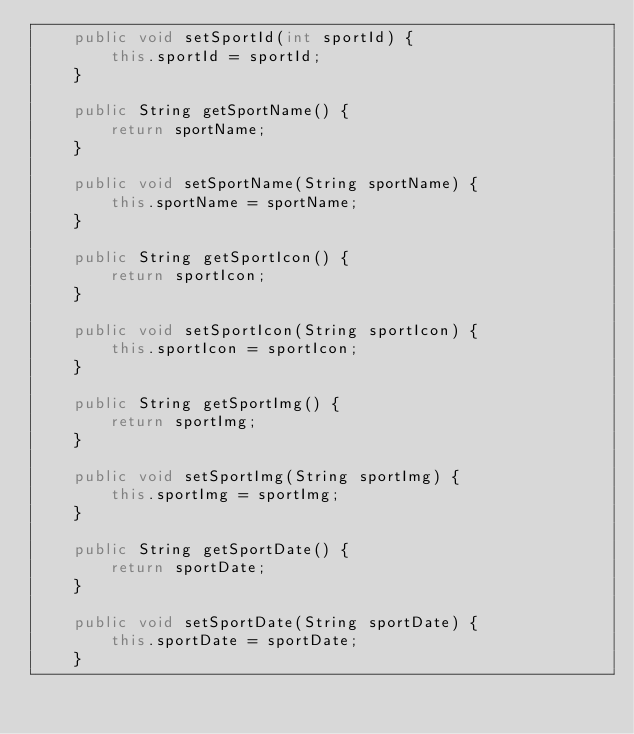Convert code to text. <code><loc_0><loc_0><loc_500><loc_500><_Java_>    public void setSportId(int sportId) {
        this.sportId = sportId;
    }

    public String getSportName() {
        return sportName;
    }

    public void setSportName(String sportName) {
        this.sportName = sportName;
    }

    public String getSportIcon() {
        return sportIcon;
    }

    public void setSportIcon(String sportIcon) {
        this.sportIcon = sportIcon;
    }

    public String getSportImg() {
        return sportImg;
    }

    public void setSportImg(String sportImg) {
        this.sportImg = sportImg;
    }

    public String getSportDate() {
        return sportDate;
    }

    public void setSportDate(String sportDate) {
        this.sportDate = sportDate;
    }
</code> 